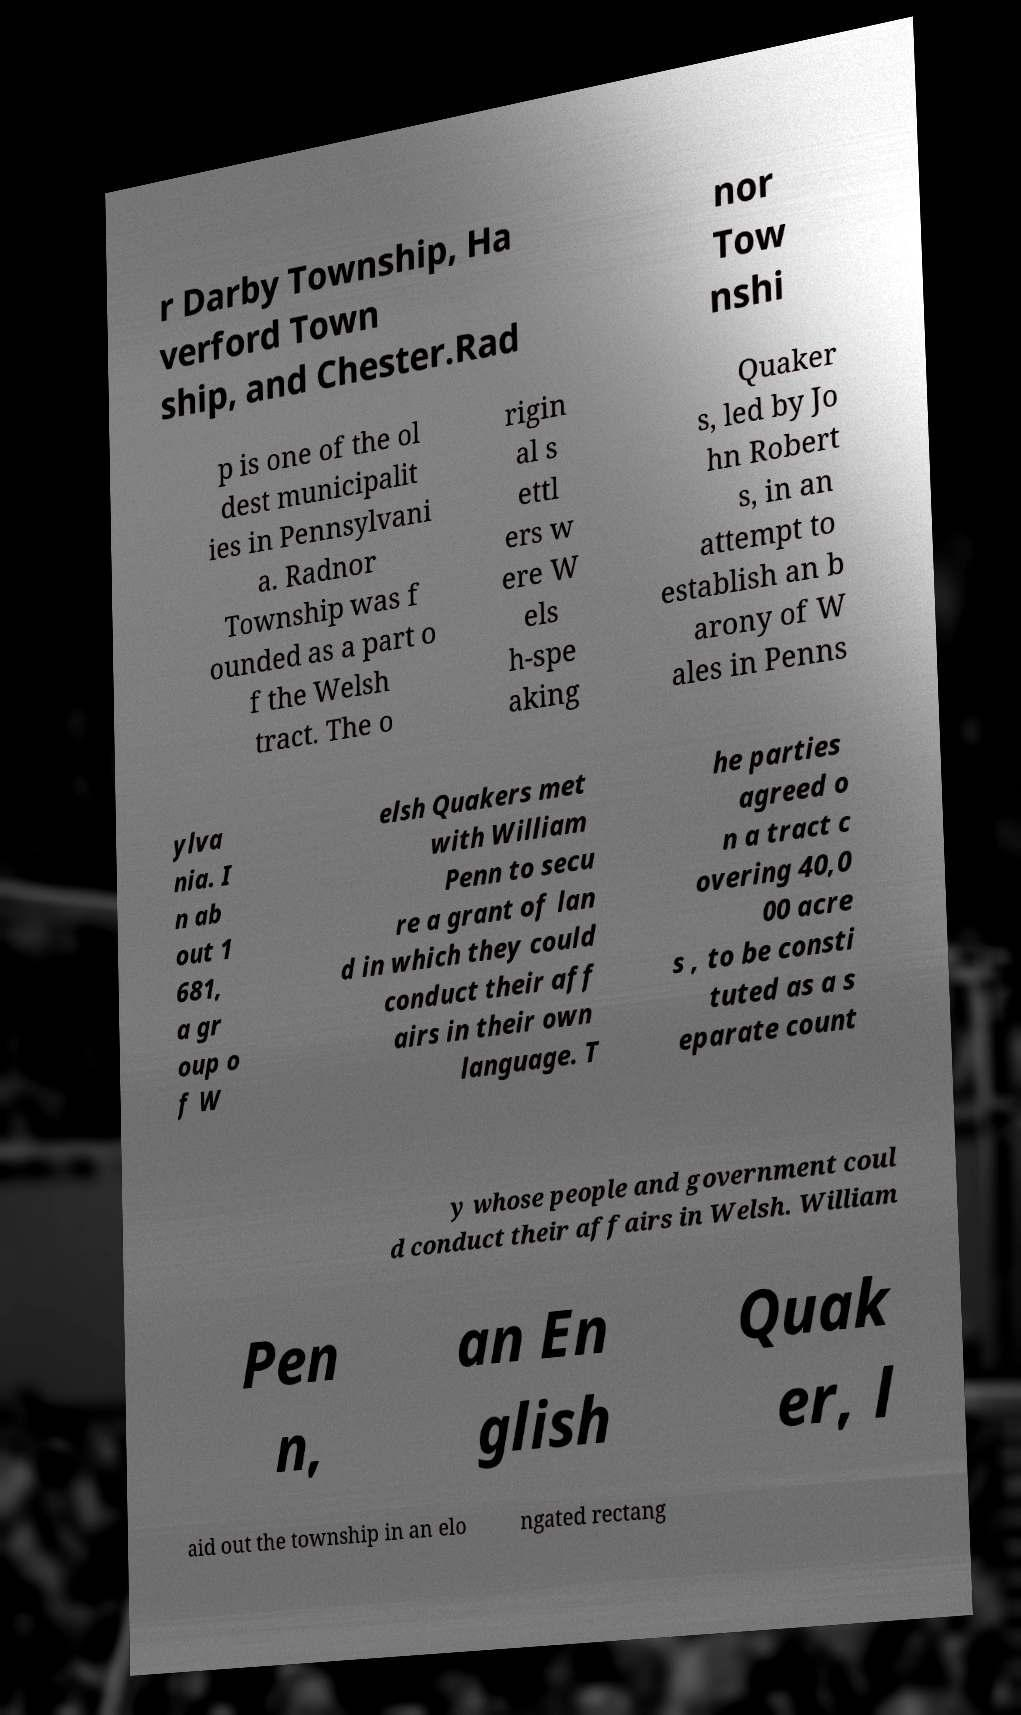For documentation purposes, I need the text within this image transcribed. Could you provide that? r Darby Township, Ha verford Town ship, and Chester.Rad nor Tow nshi p is one of the ol dest municipalit ies in Pennsylvani a. Radnor Township was f ounded as a part o f the Welsh tract. The o rigin al s ettl ers w ere W els h-spe aking Quaker s, led by Jo hn Robert s, in an attempt to establish an b arony of W ales in Penns ylva nia. I n ab out 1 681, a gr oup o f W elsh Quakers met with William Penn to secu re a grant of lan d in which they could conduct their aff airs in their own language. T he parties agreed o n a tract c overing 40,0 00 acre s , to be consti tuted as a s eparate count y whose people and government coul d conduct their affairs in Welsh. William Pen n, an En glish Quak er, l aid out the township in an elo ngated rectang 